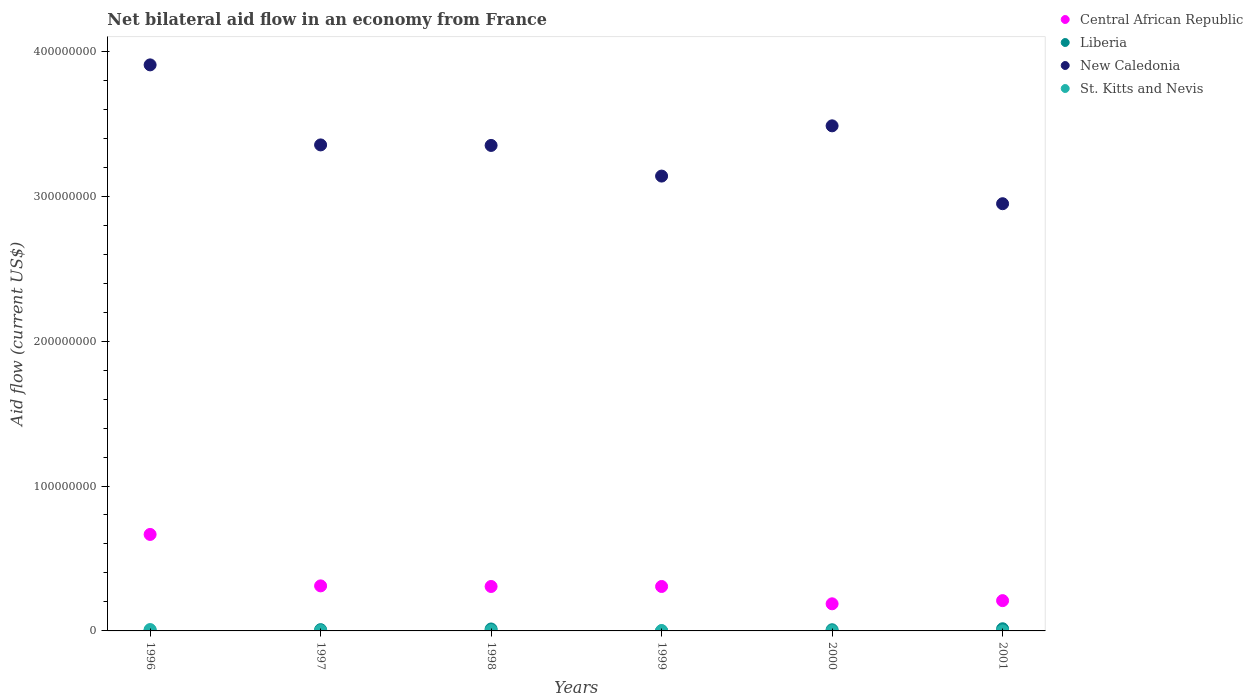How many different coloured dotlines are there?
Keep it short and to the point. 4. What is the net bilateral aid flow in Liberia in 1997?
Make the answer very short. 8.80e+05. Across all years, what is the maximum net bilateral aid flow in St. Kitts and Nevis?
Your answer should be compact. 9.40e+05. Across all years, what is the minimum net bilateral aid flow in New Caledonia?
Your response must be concise. 2.95e+08. What is the total net bilateral aid flow in New Caledonia in the graph?
Your response must be concise. 2.02e+09. What is the difference between the net bilateral aid flow in St. Kitts and Nevis in 1997 and that in 1999?
Keep it short and to the point. -4.00e+04. What is the difference between the net bilateral aid flow in Liberia in 1998 and the net bilateral aid flow in New Caledonia in 2001?
Your answer should be compact. -2.93e+08. What is the average net bilateral aid flow in St. Kitts and Nevis per year?
Your answer should be very brief. 2.92e+05. In the year 2000, what is the difference between the net bilateral aid flow in Liberia and net bilateral aid flow in Central African Republic?
Your answer should be very brief. -1.79e+07. Is the net bilateral aid flow in St. Kitts and Nevis in 1996 less than that in 1998?
Give a very brief answer. No. Is the difference between the net bilateral aid flow in Liberia in 1998 and 2001 greater than the difference between the net bilateral aid flow in Central African Republic in 1998 and 2001?
Your response must be concise. No. What is the difference between the highest and the second highest net bilateral aid flow in New Caledonia?
Offer a terse response. 4.21e+07. What is the difference between the highest and the lowest net bilateral aid flow in Central African Republic?
Ensure brevity in your answer.  4.79e+07. Is the sum of the net bilateral aid flow in Liberia in 1998 and 1999 greater than the maximum net bilateral aid flow in Central African Republic across all years?
Your response must be concise. No. Is it the case that in every year, the sum of the net bilateral aid flow in Liberia and net bilateral aid flow in St. Kitts and Nevis  is greater than the sum of net bilateral aid flow in New Caledonia and net bilateral aid flow in Central African Republic?
Keep it short and to the point. No. Does the net bilateral aid flow in New Caledonia monotonically increase over the years?
Keep it short and to the point. No. How many dotlines are there?
Make the answer very short. 4. How many years are there in the graph?
Provide a short and direct response. 6. What is the difference between two consecutive major ticks on the Y-axis?
Offer a terse response. 1.00e+08. Are the values on the major ticks of Y-axis written in scientific E-notation?
Offer a terse response. No. Does the graph contain grids?
Make the answer very short. No. Where does the legend appear in the graph?
Your answer should be very brief. Top right. How many legend labels are there?
Ensure brevity in your answer.  4. How are the legend labels stacked?
Ensure brevity in your answer.  Vertical. What is the title of the graph?
Your response must be concise. Net bilateral aid flow in an economy from France. What is the Aid flow (current US$) in Central African Republic in 1996?
Your response must be concise. 6.66e+07. What is the Aid flow (current US$) in Liberia in 1996?
Make the answer very short. 4.20e+05. What is the Aid flow (current US$) of New Caledonia in 1996?
Ensure brevity in your answer.  3.91e+08. What is the Aid flow (current US$) in St. Kitts and Nevis in 1996?
Your answer should be very brief. 9.40e+05. What is the Aid flow (current US$) in Central African Republic in 1997?
Offer a very short reply. 3.11e+07. What is the Aid flow (current US$) in Liberia in 1997?
Your answer should be very brief. 8.80e+05. What is the Aid flow (current US$) in New Caledonia in 1997?
Provide a succinct answer. 3.35e+08. What is the Aid flow (current US$) of Central African Republic in 1998?
Make the answer very short. 3.07e+07. What is the Aid flow (current US$) in Liberia in 1998?
Keep it short and to the point. 1.34e+06. What is the Aid flow (current US$) of New Caledonia in 1998?
Make the answer very short. 3.35e+08. What is the Aid flow (current US$) of St. Kitts and Nevis in 1998?
Provide a short and direct response. 2.90e+05. What is the Aid flow (current US$) in Central African Republic in 1999?
Your answer should be compact. 3.07e+07. What is the Aid flow (current US$) in New Caledonia in 1999?
Provide a short and direct response. 3.14e+08. What is the Aid flow (current US$) in Central African Republic in 2000?
Your answer should be compact. 1.87e+07. What is the Aid flow (current US$) of New Caledonia in 2000?
Provide a succinct answer. 3.49e+08. What is the Aid flow (current US$) of Central African Republic in 2001?
Keep it short and to the point. 2.09e+07. What is the Aid flow (current US$) of Liberia in 2001?
Your response must be concise. 1.49e+06. What is the Aid flow (current US$) of New Caledonia in 2001?
Provide a succinct answer. 2.95e+08. Across all years, what is the maximum Aid flow (current US$) of Central African Republic?
Make the answer very short. 6.66e+07. Across all years, what is the maximum Aid flow (current US$) of Liberia?
Your response must be concise. 1.49e+06. Across all years, what is the maximum Aid flow (current US$) in New Caledonia?
Offer a terse response. 3.91e+08. Across all years, what is the maximum Aid flow (current US$) of St. Kitts and Nevis?
Keep it short and to the point. 9.40e+05. Across all years, what is the minimum Aid flow (current US$) of Central African Republic?
Ensure brevity in your answer.  1.87e+07. Across all years, what is the minimum Aid flow (current US$) of Liberia?
Offer a terse response. 3.00e+04. Across all years, what is the minimum Aid flow (current US$) of New Caledonia?
Keep it short and to the point. 2.95e+08. What is the total Aid flow (current US$) of Central African Republic in the graph?
Offer a very short reply. 1.99e+08. What is the total Aid flow (current US$) of Liberia in the graph?
Your answer should be very brief. 4.96e+06. What is the total Aid flow (current US$) in New Caledonia in the graph?
Make the answer very short. 2.02e+09. What is the total Aid flow (current US$) in St. Kitts and Nevis in the graph?
Give a very brief answer. 1.75e+06. What is the difference between the Aid flow (current US$) in Central African Republic in 1996 and that in 1997?
Your answer should be very brief. 3.55e+07. What is the difference between the Aid flow (current US$) in Liberia in 1996 and that in 1997?
Provide a succinct answer. -4.60e+05. What is the difference between the Aid flow (current US$) in New Caledonia in 1996 and that in 1997?
Offer a terse response. 5.52e+07. What is the difference between the Aid flow (current US$) in St. Kitts and Nevis in 1996 and that in 1997?
Provide a succinct answer. 7.40e+05. What is the difference between the Aid flow (current US$) in Central African Republic in 1996 and that in 1998?
Give a very brief answer. 3.59e+07. What is the difference between the Aid flow (current US$) in Liberia in 1996 and that in 1998?
Offer a terse response. -9.20e+05. What is the difference between the Aid flow (current US$) of New Caledonia in 1996 and that in 1998?
Your answer should be compact. 5.56e+07. What is the difference between the Aid flow (current US$) in St. Kitts and Nevis in 1996 and that in 1998?
Make the answer very short. 6.50e+05. What is the difference between the Aid flow (current US$) of Central African Republic in 1996 and that in 1999?
Keep it short and to the point. 3.59e+07. What is the difference between the Aid flow (current US$) in Liberia in 1996 and that in 1999?
Give a very brief answer. 3.90e+05. What is the difference between the Aid flow (current US$) of New Caledonia in 1996 and that in 1999?
Ensure brevity in your answer.  7.67e+07. What is the difference between the Aid flow (current US$) in St. Kitts and Nevis in 1996 and that in 1999?
Your answer should be very brief. 7.00e+05. What is the difference between the Aid flow (current US$) of Central African Republic in 1996 and that in 2000?
Keep it short and to the point. 4.79e+07. What is the difference between the Aid flow (current US$) of Liberia in 1996 and that in 2000?
Offer a terse response. -3.80e+05. What is the difference between the Aid flow (current US$) in New Caledonia in 1996 and that in 2000?
Offer a very short reply. 4.21e+07. What is the difference between the Aid flow (current US$) of St. Kitts and Nevis in 1996 and that in 2000?
Your answer should be very brief. 8.90e+05. What is the difference between the Aid flow (current US$) of Central African Republic in 1996 and that in 2001?
Ensure brevity in your answer.  4.57e+07. What is the difference between the Aid flow (current US$) in Liberia in 1996 and that in 2001?
Your answer should be very brief. -1.07e+06. What is the difference between the Aid flow (current US$) of New Caledonia in 1996 and that in 2001?
Ensure brevity in your answer.  9.58e+07. What is the difference between the Aid flow (current US$) in St. Kitts and Nevis in 1996 and that in 2001?
Provide a succinct answer. 9.10e+05. What is the difference between the Aid flow (current US$) in Liberia in 1997 and that in 1998?
Your response must be concise. -4.60e+05. What is the difference between the Aid flow (current US$) of New Caledonia in 1997 and that in 1998?
Give a very brief answer. 3.60e+05. What is the difference between the Aid flow (current US$) in Central African Republic in 1997 and that in 1999?
Your answer should be very brief. 4.10e+05. What is the difference between the Aid flow (current US$) of Liberia in 1997 and that in 1999?
Your answer should be very brief. 8.50e+05. What is the difference between the Aid flow (current US$) of New Caledonia in 1997 and that in 1999?
Your response must be concise. 2.15e+07. What is the difference between the Aid flow (current US$) of Central African Republic in 1997 and that in 2000?
Offer a terse response. 1.24e+07. What is the difference between the Aid flow (current US$) of New Caledonia in 1997 and that in 2000?
Your answer should be very brief. -1.32e+07. What is the difference between the Aid flow (current US$) of Central African Republic in 1997 and that in 2001?
Your response must be concise. 1.02e+07. What is the difference between the Aid flow (current US$) in Liberia in 1997 and that in 2001?
Give a very brief answer. -6.10e+05. What is the difference between the Aid flow (current US$) in New Caledonia in 1997 and that in 2001?
Keep it short and to the point. 4.06e+07. What is the difference between the Aid flow (current US$) in Central African Republic in 1998 and that in 1999?
Make the answer very short. 0. What is the difference between the Aid flow (current US$) in Liberia in 1998 and that in 1999?
Your response must be concise. 1.31e+06. What is the difference between the Aid flow (current US$) of New Caledonia in 1998 and that in 1999?
Give a very brief answer. 2.12e+07. What is the difference between the Aid flow (current US$) of Central African Republic in 1998 and that in 2000?
Provide a short and direct response. 1.20e+07. What is the difference between the Aid flow (current US$) of Liberia in 1998 and that in 2000?
Your response must be concise. 5.40e+05. What is the difference between the Aid flow (current US$) of New Caledonia in 1998 and that in 2000?
Provide a short and direct response. -1.35e+07. What is the difference between the Aid flow (current US$) of St. Kitts and Nevis in 1998 and that in 2000?
Offer a terse response. 2.40e+05. What is the difference between the Aid flow (current US$) in Central African Republic in 1998 and that in 2001?
Offer a very short reply. 9.77e+06. What is the difference between the Aid flow (current US$) in Liberia in 1998 and that in 2001?
Ensure brevity in your answer.  -1.50e+05. What is the difference between the Aid flow (current US$) in New Caledonia in 1998 and that in 2001?
Offer a terse response. 4.02e+07. What is the difference between the Aid flow (current US$) of St. Kitts and Nevis in 1998 and that in 2001?
Offer a terse response. 2.60e+05. What is the difference between the Aid flow (current US$) of Central African Republic in 1999 and that in 2000?
Ensure brevity in your answer.  1.20e+07. What is the difference between the Aid flow (current US$) in Liberia in 1999 and that in 2000?
Provide a short and direct response. -7.70e+05. What is the difference between the Aid flow (current US$) of New Caledonia in 1999 and that in 2000?
Your answer should be compact. -3.47e+07. What is the difference between the Aid flow (current US$) of St. Kitts and Nevis in 1999 and that in 2000?
Your response must be concise. 1.90e+05. What is the difference between the Aid flow (current US$) in Central African Republic in 1999 and that in 2001?
Offer a terse response. 9.77e+06. What is the difference between the Aid flow (current US$) in Liberia in 1999 and that in 2001?
Give a very brief answer. -1.46e+06. What is the difference between the Aid flow (current US$) in New Caledonia in 1999 and that in 2001?
Offer a terse response. 1.91e+07. What is the difference between the Aid flow (current US$) in Central African Republic in 2000 and that in 2001?
Provide a succinct answer. -2.19e+06. What is the difference between the Aid flow (current US$) of Liberia in 2000 and that in 2001?
Your answer should be very brief. -6.90e+05. What is the difference between the Aid flow (current US$) of New Caledonia in 2000 and that in 2001?
Offer a terse response. 5.37e+07. What is the difference between the Aid flow (current US$) in Central African Republic in 1996 and the Aid flow (current US$) in Liberia in 1997?
Offer a terse response. 6.57e+07. What is the difference between the Aid flow (current US$) in Central African Republic in 1996 and the Aid flow (current US$) in New Caledonia in 1997?
Your answer should be compact. -2.69e+08. What is the difference between the Aid flow (current US$) in Central African Republic in 1996 and the Aid flow (current US$) in St. Kitts and Nevis in 1997?
Offer a terse response. 6.64e+07. What is the difference between the Aid flow (current US$) in Liberia in 1996 and the Aid flow (current US$) in New Caledonia in 1997?
Ensure brevity in your answer.  -3.35e+08. What is the difference between the Aid flow (current US$) in Liberia in 1996 and the Aid flow (current US$) in St. Kitts and Nevis in 1997?
Offer a terse response. 2.20e+05. What is the difference between the Aid flow (current US$) in New Caledonia in 1996 and the Aid flow (current US$) in St. Kitts and Nevis in 1997?
Offer a terse response. 3.90e+08. What is the difference between the Aid flow (current US$) in Central African Republic in 1996 and the Aid flow (current US$) in Liberia in 1998?
Offer a very short reply. 6.52e+07. What is the difference between the Aid flow (current US$) in Central African Republic in 1996 and the Aid flow (current US$) in New Caledonia in 1998?
Ensure brevity in your answer.  -2.68e+08. What is the difference between the Aid flow (current US$) in Central African Republic in 1996 and the Aid flow (current US$) in St. Kitts and Nevis in 1998?
Offer a very short reply. 6.63e+07. What is the difference between the Aid flow (current US$) in Liberia in 1996 and the Aid flow (current US$) in New Caledonia in 1998?
Offer a terse response. -3.35e+08. What is the difference between the Aid flow (current US$) in Liberia in 1996 and the Aid flow (current US$) in St. Kitts and Nevis in 1998?
Offer a terse response. 1.30e+05. What is the difference between the Aid flow (current US$) in New Caledonia in 1996 and the Aid flow (current US$) in St. Kitts and Nevis in 1998?
Make the answer very short. 3.90e+08. What is the difference between the Aid flow (current US$) of Central African Republic in 1996 and the Aid flow (current US$) of Liberia in 1999?
Make the answer very short. 6.66e+07. What is the difference between the Aid flow (current US$) of Central African Republic in 1996 and the Aid flow (current US$) of New Caledonia in 1999?
Offer a very short reply. -2.47e+08. What is the difference between the Aid flow (current US$) of Central African Republic in 1996 and the Aid flow (current US$) of St. Kitts and Nevis in 1999?
Provide a succinct answer. 6.63e+07. What is the difference between the Aid flow (current US$) in Liberia in 1996 and the Aid flow (current US$) in New Caledonia in 1999?
Give a very brief answer. -3.13e+08. What is the difference between the Aid flow (current US$) in New Caledonia in 1996 and the Aid flow (current US$) in St. Kitts and Nevis in 1999?
Your answer should be very brief. 3.90e+08. What is the difference between the Aid flow (current US$) in Central African Republic in 1996 and the Aid flow (current US$) in Liberia in 2000?
Provide a short and direct response. 6.58e+07. What is the difference between the Aid flow (current US$) in Central African Republic in 1996 and the Aid flow (current US$) in New Caledonia in 2000?
Your response must be concise. -2.82e+08. What is the difference between the Aid flow (current US$) of Central African Republic in 1996 and the Aid flow (current US$) of St. Kitts and Nevis in 2000?
Offer a very short reply. 6.65e+07. What is the difference between the Aid flow (current US$) in Liberia in 1996 and the Aid flow (current US$) in New Caledonia in 2000?
Provide a short and direct response. -3.48e+08. What is the difference between the Aid flow (current US$) in Liberia in 1996 and the Aid flow (current US$) in St. Kitts and Nevis in 2000?
Offer a very short reply. 3.70e+05. What is the difference between the Aid flow (current US$) of New Caledonia in 1996 and the Aid flow (current US$) of St. Kitts and Nevis in 2000?
Ensure brevity in your answer.  3.91e+08. What is the difference between the Aid flow (current US$) in Central African Republic in 1996 and the Aid flow (current US$) in Liberia in 2001?
Give a very brief answer. 6.51e+07. What is the difference between the Aid flow (current US$) of Central African Republic in 1996 and the Aid flow (current US$) of New Caledonia in 2001?
Give a very brief answer. -2.28e+08. What is the difference between the Aid flow (current US$) of Central African Republic in 1996 and the Aid flow (current US$) of St. Kitts and Nevis in 2001?
Offer a very short reply. 6.66e+07. What is the difference between the Aid flow (current US$) in Liberia in 1996 and the Aid flow (current US$) in New Caledonia in 2001?
Make the answer very short. -2.94e+08. What is the difference between the Aid flow (current US$) of New Caledonia in 1996 and the Aid flow (current US$) of St. Kitts and Nevis in 2001?
Give a very brief answer. 3.91e+08. What is the difference between the Aid flow (current US$) in Central African Republic in 1997 and the Aid flow (current US$) in Liberia in 1998?
Provide a succinct answer. 2.97e+07. What is the difference between the Aid flow (current US$) of Central African Republic in 1997 and the Aid flow (current US$) of New Caledonia in 1998?
Give a very brief answer. -3.04e+08. What is the difference between the Aid flow (current US$) in Central African Republic in 1997 and the Aid flow (current US$) in St. Kitts and Nevis in 1998?
Keep it short and to the point. 3.08e+07. What is the difference between the Aid flow (current US$) of Liberia in 1997 and the Aid flow (current US$) of New Caledonia in 1998?
Your response must be concise. -3.34e+08. What is the difference between the Aid flow (current US$) of Liberia in 1997 and the Aid flow (current US$) of St. Kitts and Nevis in 1998?
Your response must be concise. 5.90e+05. What is the difference between the Aid flow (current US$) of New Caledonia in 1997 and the Aid flow (current US$) of St. Kitts and Nevis in 1998?
Offer a very short reply. 3.35e+08. What is the difference between the Aid flow (current US$) in Central African Republic in 1997 and the Aid flow (current US$) in Liberia in 1999?
Offer a very short reply. 3.10e+07. What is the difference between the Aid flow (current US$) of Central African Republic in 1997 and the Aid flow (current US$) of New Caledonia in 1999?
Give a very brief answer. -2.83e+08. What is the difference between the Aid flow (current US$) in Central African Republic in 1997 and the Aid flow (current US$) in St. Kitts and Nevis in 1999?
Provide a succinct answer. 3.08e+07. What is the difference between the Aid flow (current US$) in Liberia in 1997 and the Aid flow (current US$) in New Caledonia in 1999?
Your answer should be compact. -3.13e+08. What is the difference between the Aid flow (current US$) in Liberia in 1997 and the Aid flow (current US$) in St. Kitts and Nevis in 1999?
Make the answer very short. 6.40e+05. What is the difference between the Aid flow (current US$) of New Caledonia in 1997 and the Aid flow (current US$) of St. Kitts and Nevis in 1999?
Ensure brevity in your answer.  3.35e+08. What is the difference between the Aid flow (current US$) of Central African Republic in 1997 and the Aid flow (current US$) of Liberia in 2000?
Offer a terse response. 3.03e+07. What is the difference between the Aid flow (current US$) in Central African Republic in 1997 and the Aid flow (current US$) in New Caledonia in 2000?
Keep it short and to the point. -3.17e+08. What is the difference between the Aid flow (current US$) of Central African Republic in 1997 and the Aid flow (current US$) of St. Kitts and Nevis in 2000?
Offer a very short reply. 3.10e+07. What is the difference between the Aid flow (current US$) of Liberia in 1997 and the Aid flow (current US$) of New Caledonia in 2000?
Keep it short and to the point. -3.48e+08. What is the difference between the Aid flow (current US$) of Liberia in 1997 and the Aid flow (current US$) of St. Kitts and Nevis in 2000?
Your response must be concise. 8.30e+05. What is the difference between the Aid flow (current US$) in New Caledonia in 1997 and the Aid flow (current US$) in St. Kitts and Nevis in 2000?
Your response must be concise. 3.35e+08. What is the difference between the Aid flow (current US$) in Central African Republic in 1997 and the Aid flow (current US$) in Liberia in 2001?
Provide a succinct answer. 2.96e+07. What is the difference between the Aid flow (current US$) of Central African Republic in 1997 and the Aid flow (current US$) of New Caledonia in 2001?
Your answer should be very brief. -2.64e+08. What is the difference between the Aid flow (current US$) in Central African Republic in 1997 and the Aid flow (current US$) in St. Kitts and Nevis in 2001?
Give a very brief answer. 3.10e+07. What is the difference between the Aid flow (current US$) in Liberia in 1997 and the Aid flow (current US$) in New Caledonia in 2001?
Give a very brief answer. -2.94e+08. What is the difference between the Aid flow (current US$) of Liberia in 1997 and the Aid flow (current US$) of St. Kitts and Nevis in 2001?
Provide a short and direct response. 8.50e+05. What is the difference between the Aid flow (current US$) of New Caledonia in 1997 and the Aid flow (current US$) of St. Kitts and Nevis in 2001?
Ensure brevity in your answer.  3.35e+08. What is the difference between the Aid flow (current US$) of Central African Republic in 1998 and the Aid flow (current US$) of Liberia in 1999?
Offer a very short reply. 3.06e+07. What is the difference between the Aid flow (current US$) of Central African Republic in 1998 and the Aid flow (current US$) of New Caledonia in 1999?
Offer a very short reply. -2.83e+08. What is the difference between the Aid flow (current US$) of Central African Republic in 1998 and the Aid flow (current US$) of St. Kitts and Nevis in 1999?
Make the answer very short. 3.04e+07. What is the difference between the Aid flow (current US$) in Liberia in 1998 and the Aid flow (current US$) in New Caledonia in 1999?
Your answer should be compact. -3.13e+08. What is the difference between the Aid flow (current US$) in Liberia in 1998 and the Aid flow (current US$) in St. Kitts and Nevis in 1999?
Give a very brief answer. 1.10e+06. What is the difference between the Aid flow (current US$) of New Caledonia in 1998 and the Aid flow (current US$) of St. Kitts and Nevis in 1999?
Give a very brief answer. 3.35e+08. What is the difference between the Aid flow (current US$) in Central African Republic in 1998 and the Aid flow (current US$) in Liberia in 2000?
Your response must be concise. 2.99e+07. What is the difference between the Aid flow (current US$) of Central African Republic in 1998 and the Aid flow (current US$) of New Caledonia in 2000?
Provide a succinct answer. -3.18e+08. What is the difference between the Aid flow (current US$) in Central African Republic in 1998 and the Aid flow (current US$) in St. Kitts and Nevis in 2000?
Your answer should be very brief. 3.06e+07. What is the difference between the Aid flow (current US$) of Liberia in 1998 and the Aid flow (current US$) of New Caledonia in 2000?
Your response must be concise. -3.47e+08. What is the difference between the Aid flow (current US$) of Liberia in 1998 and the Aid flow (current US$) of St. Kitts and Nevis in 2000?
Offer a very short reply. 1.29e+06. What is the difference between the Aid flow (current US$) in New Caledonia in 1998 and the Aid flow (current US$) in St. Kitts and Nevis in 2000?
Provide a succinct answer. 3.35e+08. What is the difference between the Aid flow (current US$) in Central African Republic in 1998 and the Aid flow (current US$) in Liberia in 2001?
Your response must be concise. 2.92e+07. What is the difference between the Aid flow (current US$) in Central African Republic in 1998 and the Aid flow (current US$) in New Caledonia in 2001?
Your answer should be compact. -2.64e+08. What is the difference between the Aid flow (current US$) of Central African Republic in 1998 and the Aid flow (current US$) of St. Kitts and Nevis in 2001?
Your response must be concise. 3.06e+07. What is the difference between the Aid flow (current US$) of Liberia in 1998 and the Aid flow (current US$) of New Caledonia in 2001?
Provide a succinct answer. -2.93e+08. What is the difference between the Aid flow (current US$) in Liberia in 1998 and the Aid flow (current US$) in St. Kitts and Nevis in 2001?
Give a very brief answer. 1.31e+06. What is the difference between the Aid flow (current US$) of New Caledonia in 1998 and the Aid flow (current US$) of St. Kitts and Nevis in 2001?
Make the answer very short. 3.35e+08. What is the difference between the Aid flow (current US$) of Central African Republic in 1999 and the Aid flow (current US$) of Liberia in 2000?
Offer a terse response. 2.99e+07. What is the difference between the Aid flow (current US$) of Central African Republic in 1999 and the Aid flow (current US$) of New Caledonia in 2000?
Ensure brevity in your answer.  -3.18e+08. What is the difference between the Aid flow (current US$) of Central African Republic in 1999 and the Aid flow (current US$) of St. Kitts and Nevis in 2000?
Provide a succinct answer. 3.06e+07. What is the difference between the Aid flow (current US$) of Liberia in 1999 and the Aid flow (current US$) of New Caledonia in 2000?
Your answer should be compact. -3.49e+08. What is the difference between the Aid flow (current US$) of Liberia in 1999 and the Aid flow (current US$) of St. Kitts and Nevis in 2000?
Make the answer very short. -2.00e+04. What is the difference between the Aid flow (current US$) in New Caledonia in 1999 and the Aid flow (current US$) in St. Kitts and Nevis in 2000?
Provide a short and direct response. 3.14e+08. What is the difference between the Aid flow (current US$) of Central African Republic in 1999 and the Aid flow (current US$) of Liberia in 2001?
Offer a very short reply. 2.92e+07. What is the difference between the Aid flow (current US$) in Central African Republic in 1999 and the Aid flow (current US$) in New Caledonia in 2001?
Make the answer very short. -2.64e+08. What is the difference between the Aid flow (current US$) in Central African Republic in 1999 and the Aid flow (current US$) in St. Kitts and Nevis in 2001?
Your response must be concise. 3.06e+07. What is the difference between the Aid flow (current US$) in Liberia in 1999 and the Aid flow (current US$) in New Caledonia in 2001?
Give a very brief answer. -2.95e+08. What is the difference between the Aid flow (current US$) in New Caledonia in 1999 and the Aid flow (current US$) in St. Kitts and Nevis in 2001?
Provide a short and direct response. 3.14e+08. What is the difference between the Aid flow (current US$) of Central African Republic in 2000 and the Aid flow (current US$) of Liberia in 2001?
Keep it short and to the point. 1.72e+07. What is the difference between the Aid flow (current US$) of Central African Republic in 2000 and the Aid flow (current US$) of New Caledonia in 2001?
Your response must be concise. -2.76e+08. What is the difference between the Aid flow (current US$) in Central African Republic in 2000 and the Aid flow (current US$) in St. Kitts and Nevis in 2001?
Provide a succinct answer. 1.87e+07. What is the difference between the Aid flow (current US$) of Liberia in 2000 and the Aid flow (current US$) of New Caledonia in 2001?
Offer a very short reply. -2.94e+08. What is the difference between the Aid flow (current US$) in Liberia in 2000 and the Aid flow (current US$) in St. Kitts and Nevis in 2001?
Provide a succinct answer. 7.70e+05. What is the difference between the Aid flow (current US$) of New Caledonia in 2000 and the Aid flow (current US$) of St. Kitts and Nevis in 2001?
Your response must be concise. 3.49e+08. What is the average Aid flow (current US$) of Central African Republic per year?
Ensure brevity in your answer.  3.31e+07. What is the average Aid flow (current US$) of Liberia per year?
Provide a succinct answer. 8.27e+05. What is the average Aid flow (current US$) in New Caledonia per year?
Ensure brevity in your answer.  3.36e+08. What is the average Aid flow (current US$) in St. Kitts and Nevis per year?
Make the answer very short. 2.92e+05. In the year 1996, what is the difference between the Aid flow (current US$) of Central African Republic and Aid flow (current US$) of Liberia?
Your response must be concise. 6.62e+07. In the year 1996, what is the difference between the Aid flow (current US$) in Central African Republic and Aid flow (current US$) in New Caledonia?
Provide a short and direct response. -3.24e+08. In the year 1996, what is the difference between the Aid flow (current US$) of Central African Republic and Aid flow (current US$) of St. Kitts and Nevis?
Make the answer very short. 6.56e+07. In the year 1996, what is the difference between the Aid flow (current US$) of Liberia and Aid flow (current US$) of New Caledonia?
Your answer should be compact. -3.90e+08. In the year 1996, what is the difference between the Aid flow (current US$) in Liberia and Aid flow (current US$) in St. Kitts and Nevis?
Your response must be concise. -5.20e+05. In the year 1996, what is the difference between the Aid flow (current US$) of New Caledonia and Aid flow (current US$) of St. Kitts and Nevis?
Keep it short and to the point. 3.90e+08. In the year 1997, what is the difference between the Aid flow (current US$) of Central African Republic and Aid flow (current US$) of Liberia?
Provide a succinct answer. 3.02e+07. In the year 1997, what is the difference between the Aid flow (current US$) of Central African Republic and Aid flow (current US$) of New Caledonia?
Your response must be concise. -3.04e+08. In the year 1997, what is the difference between the Aid flow (current US$) in Central African Republic and Aid flow (current US$) in St. Kitts and Nevis?
Your response must be concise. 3.09e+07. In the year 1997, what is the difference between the Aid flow (current US$) of Liberia and Aid flow (current US$) of New Caledonia?
Make the answer very short. -3.34e+08. In the year 1997, what is the difference between the Aid flow (current US$) of Liberia and Aid flow (current US$) of St. Kitts and Nevis?
Your answer should be compact. 6.80e+05. In the year 1997, what is the difference between the Aid flow (current US$) in New Caledonia and Aid flow (current US$) in St. Kitts and Nevis?
Offer a terse response. 3.35e+08. In the year 1998, what is the difference between the Aid flow (current US$) of Central African Republic and Aid flow (current US$) of Liberia?
Your response must be concise. 2.93e+07. In the year 1998, what is the difference between the Aid flow (current US$) in Central African Republic and Aid flow (current US$) in New Caledonia?
Offer a very short reply. -3.04e+08. In the year 1998, what is the difference between the Aid flow (current US$) of Central African Republic and Aid flow (current US$) of St. Kitts and Nevis?
Offer a terse response. 3.04e+07. In the year 1998, what is the difference between the Aid flow (current US$) of Liberia and Aid flow (current US$) of New Caledonia?
Offer a very short reply. -3.34e+08. In the year 1998, what is the difference between the Aid flow (current US$) in Liberia and Aid flow (current US$) in St. Kitts and Nevis?
Provide a short and direct response. 1.05e+06. In the year 1998, what is the difference between the Aid flow (current US$) of New Caledonia and Aid flow (current US$) of St. Kitts and Nevis?
Your answer should be compact. 3.35e+08. In the year 1999, what is the difference between the Aid flow (current US$) in Central African Republic and Aid flow (current US$) in Liberia?
Your answer should be compact. 3.06e+07. In the year 1999, what is the difference between the Aid flow (current US$) of Central African Republic and Aid flow (current US$) of New Caledonia?
Keep it short and to the point. -2.83e+08. In the year 1999, what is the difference between the Aid flow (current US$) in Central African Republic and Aid flow (current US$) in St. Kitts and Nevis?
Keep it short and to the point. 3.04e+07. In the year 1999, what is the difference between the Aid flow (current US$) in Liberia and Aid flow (current US$) in New Caledonia?
Your answer should be compact. -3.14e+08. In the year 1999, what is the difference between the Aid flow (current US$) of Liberia and Aid flow (current US$) of St. Kitts and Nevis?
Provide a succinct answer. -2.10e+05. In the year 1999, what is the difference between the Aid flow (current US$) in New Caledonia and Aid flow (current US$) in St. Kitts and Nevis?
Give a very brief answer. 3.14e+08. In the year 2000, what is the difference between the Aid flow (current US$) of Central African Republic and Aid flow (current US$) of Liberia?
Provide a succinct answer. 1.79e+07. In the year 2000, what is the difference between the Aid flow (current US$) of Central African Republic and Aid flow (current US$) of New Caledonia?
Give a very brief answer. -3.30e+08. In the year 2000, what is the difference between the Aid flow (current US$) of Central African Republic and Aid flow (current US$) of St. Kitts and Nevis?
Offer a terse response. 1.87e+07. In the year 2000, what is the difference between the Aid flow (current US$) of Liberia and Aid flow (current US$) of New Caledonia?
Your answer should be very brief. -3.48e+08. In the year 2000, what is the difference between the Aid flow (current US$) in Liberia and Aid flow (current US$) in St. Kitts and Nevis?
Keep it short and to the point. 7.50e+05. In the year 2000, what is the difference between the Aid flow (current US$) in New Caledonia and Aid flow (current US$) in St. Kitts and Nevis?
Provide a short and direct response. 3.48e+08. In the year 2001, what is the difference between the Aid flow (current US$) in Central African Republic and Aid flow (current US$) in Liberia?
Provide a succinct answer. 1.94e+07. In the year 2001, what is the difference between the Aid flow (current US$) in Central African Republic and Aid flow (current US$) in New Caledonia?
Offer a very short reply. -2.74e+08. In the year 2001, what is the difference between the Aid flow (current US$) of Central African Republic and Aid flow (current US$) of St. Kitts and Nevis?
Keep it short and to the point. 2.09e+07. In the year 2001, what is the difference between the Aid flow (current US$) in Liberia and Aid flow (current US$) in New Caledonia?
Keep it short and to the point. -2.93e+08. In the year 2001, what is the difference between the Aid flow (current US$) of Liberia and Aid flow (current US$) of St. Kitts and Nevis?
Provide a succinct answer. 1.46e+06. In the year 2001, what is the difference between the Aid flow (current US$) in New Caledonia and Aid flow (current US$) in St. Kitts and Nevis?
Keep it short and to the point. 2.95e+08. What is the ratio of the Aid flow (current US$) of Central African Republic in 1996 to that in 1997?
Ensure brevity in your answer.  2.14. What is the ratio of the Aid flow (current US$) in Liberia in 1996 to that in 1997?
Your answer should be compact. 0.48. What is the ratio of the Aid flow (current US$) in New Caledonia in 1996 to that in 1997?
Provide a succinct answer. 1.16. What is the ratio of the Aid flow (current US$) of St. Kitts and Nevis in 1996 to that in 1997?
Make the answer very short. 4.7. What is the ratio of the Aid flow (current US$) in Central African Republic in 1996 to that in 1998?
Your answer should be very brief. 2.17. What is the ratio of the Aid flow (current US$) in Liberia in 1996 to that in 1998?
Keep it short and to the point. 0.31. What is the ratio of the Aid flow (current US$) of New Caledonia in 1996 to that in 1998?
Make the answer very short. 1.17. What is the ratio of the Aid flow (current US$) in St. Kitts and Nevis in 1996 to that in 1998?
Ensure brevity in your answer.  3.24. What is the ratio of the Aid flow (current US$) in Central African Republic in 1996 to that in 1999?
Offer a terse response. 2.17. What is the ratio of the Aid flow (current US$) of Liberia in 1996 to that in 1999?
Your response must be concise. 14. What is the ratio of the Aid flow (current US$) of New Caledonia in 1996 to that in 1999?
Keep it short and to the point. 1.24. What is the ratio of the Aid flow (current US$) of St. Kitts and Nevis in 1996 to that in 1999?
Your answer should be compact. 3.92. What is the ratio of the Aid flow (current US$) in Central African Republic in 1996 to that in 2000?
Offer a very short reply. 3.56. What is the ratio of the Aid flow (current US$) in Liberia in 1996 to that in 2000?
Your response must be concise. 0.53. What is the ratio of the Aid flow (current US$) of New Caledonia in 1996 to that in 2000?
Make the answer very short. 1.12. What is the ratio of the Aid flow (current US$) of St. Kitts and Nevis in 1996 to that in 2000?
Your answer should be very brief. 18.8. What is the ratio of the Aid flow (current US$) of Central African Republic in 1996 to that in 2001?
Make the answer very short. 3.19. What is the ratio of the Aid flow (current US$) of Liberia in 1996 to that in 2001?
Your answer should be compact. 0.28. What is the ratio of the Aid flow (current US$) in New Caledonia in 1996 to that in 2001?
Provide a short and direct response. 1.32. What is the ratio of the Aid flow (current US$) in St. Kitts and Nevis in 1996 to that in 2001?
Make the answer very short. 31.33. What is the ratio of the Aid flow (current US$) in Central African Republic in 1997 to that in 1998?
Keep it short and to the point. 1.01. What is the ratio of the Aid flow (current US$) of Liberia in 1997 to that in 1998?
Provide a succinct answer. 0.66. What is the ratio of the Aid flow (current US$) of St. Kitts and Nevis in 1997 to that in 1998?
Provide a succinct answer. 0.69. What is the ratio of the Aid flow (current US$) of Central African Republic in 1997 to that in 1999?
Give a very brief answer. 1.01. What is the ratio of the Aid flow (current US$) of Liberia in 1997 to that in 1999?
Your answer should be compact. 29.33. What is the ratio of the Aid flow (current US$) of New Caledonia in 1997 to that in 1999?
Provide a succinct answer. 1.07. What is the ratio of the Aid flow (current US$) of St. Kitts and Nevis in 1997 to that in 1999?
Provide a short and direct response. 0.83. What is the ratio of the Aid flow (current US$) in Central African Republic in 1997 to that in 2000?
Provide a succinct answer. 1.66. What is the ratio of the Aid flow (current US$) in New Caledonia in 1997 to that in 2000?
Keep it short and to the point. 0.96. What is the ratio of the Aid flow (current US$) of St. Kitts and Nevis in 1997 to that in 2000?
Ensure brevity in your answer.  4. What is the ratio of the Aid flow (current US$) in Central African Republic in 1997 to that in 2001?
Provide a short and direct response. 1.49. What is the ratio of the Aid flow (current US$) of Liberia in 1997 to that in 2001?
Provide a succinct answer. 0.59. What is the ratio of the Aid flow (current US$) of New Caledonia in 1997 to that in 2001?
Give a very brief answer. 1.14. What is the ratio of the Aid flow (current US$) in Liberia in 1998 to that in 1999?
Give a very brief answer. 44.67. What is the ratio of the Aid flow (current US$) in New Caledonia in 1998 to that in 1999?
Your answer should be compact. 1.07. What is the ratio of the Aid flow (current US$) in St. Kitts and Nevis in 1998 to that in 1999?
Your answer should be very brief. 1.21. What is the ratio of the Aid flow (current US$) in Central African Republic in 1998 to that in 2000?
Ensure brevity in your answer.  1.64. What is the ratio of the Aid flow (current US$) of Liberia in 1998 to that in 2000?
Offer a terse response. 1.68. What is the ratio of the Aid flow (current US$) of New Caledonia in 1998 to that in 2000?
Provide a short and direct response. 0.96. What is the ratio of the Aid flow (current US$) in St. Kitts and Nevis in 1998 to that in 2000?
Your response must be concise. 5.8. What is the ratio of the Aid flow (current US$) of Central African Republic in 1998 to that in 2001?
Your answer should be very brief. 1.47. What is the ratio of the Aid flow (current US$) of Liberia in 1998 to that in 2001?
Give a very brief answer. 0.9. What is the ratio of the Aid flow (current US$) of New Caledonia in 1998 to that in 2001?
Make the answer very short. 1.14. What is the ratio of the Aid flow (current US$) of St. Kitts and Nevis in 1998 to that in 2001?
Provide a short and direct response. 9.67. What is the ratio of the Aid flow (current US$) in Central African Republic in 1999 to that in 2000?
Offer a terse response. 1.64. What is the ratio of the Aid flow (current US$) in Liberia in 1999 to that in 2000?
Provide a short and direct response. 0.04. What is the ratio of the Aid flow (current US$) in New Caledonia in 1999 to that in 2000?
Ensure brevity in your answer.  0.9. What is the ratio of the Aid flow (current US$) in Central African Republic in 1999 to that in 2001?
Offer a terse response. 1.47. What is the ratio of the Aid flow (current US$) of Liberia in 1999 to that in 2001?
Provide a short and direct response. 0.02. What is the ratio of the Aid flow (current US$) of New Caledonia in 1999 to that in 2001?
Your answer should be compact. 1.06. What is the ratio of the Aid flow (current US$) of Central African Republic in 2000 to that in 2001?
Give a very brief answer. 0.9. What is the ratio of the Aid flow (current US$) of Liberia in 2000 to that in 2001?
Keep it short and to the point. 0.54. What is the ratio of the Aid flow (current US$) of New Caledonia in 2000 to that in 2001?
Keep it short and to the point. 1.18. What is the difference between the highest and the second highest Aid flow (current US$) of Central African Republic?
Your response must be concise. 3.55e+07. What is the difference between the highest and the second highest Aid flow (current US$) in Liberia?
Your answer should be very brief. 1.50e+05. What is the difference between the highest and the second highest Aid flow (current US$) of New Caledonia?
Your response must be concise. 4.21e+07. What is the difference between the highest and the second highest Aid flow (current US$) in St. Kitts and Nevis?
Your answer should be very brief. 6.50e+05. What is the difference between the highest and the lowest Aid flow (current US$) in Central African Republic?
Keep it short and to the point. 4.79e+07. What is the difference between the highest and the lowest Aid flow (current US$) in Liberia?
Give a very brief answer. 1.46e+06. What is the difference between the highest and the lowest Aid flow (current US$) of New Caledonia?
Keep it short and to the point. 9.58e+07. What is the difference between the highest and the lowest Aid flow (current US$) of St. Kitts and Nevis?
Your answer should be compact. 9.10e+05. 